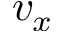Convert formula to latex. <formula><loc_0><loc_0><loc_500><loc_500>v _ { x }</formula> 